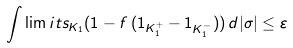<formula> <loc_0><loc_0><loc_500><loc_500>\int \lim i t s _ { K _ { 1 } } ( 1 - f \, ( { 1 } _ { K _ { 1 } ^ { + } } - { 1 } _ { K _ { 1 } ^ { - } } ) ) \, d | \sigma | \leq \varepsilon</formula> 